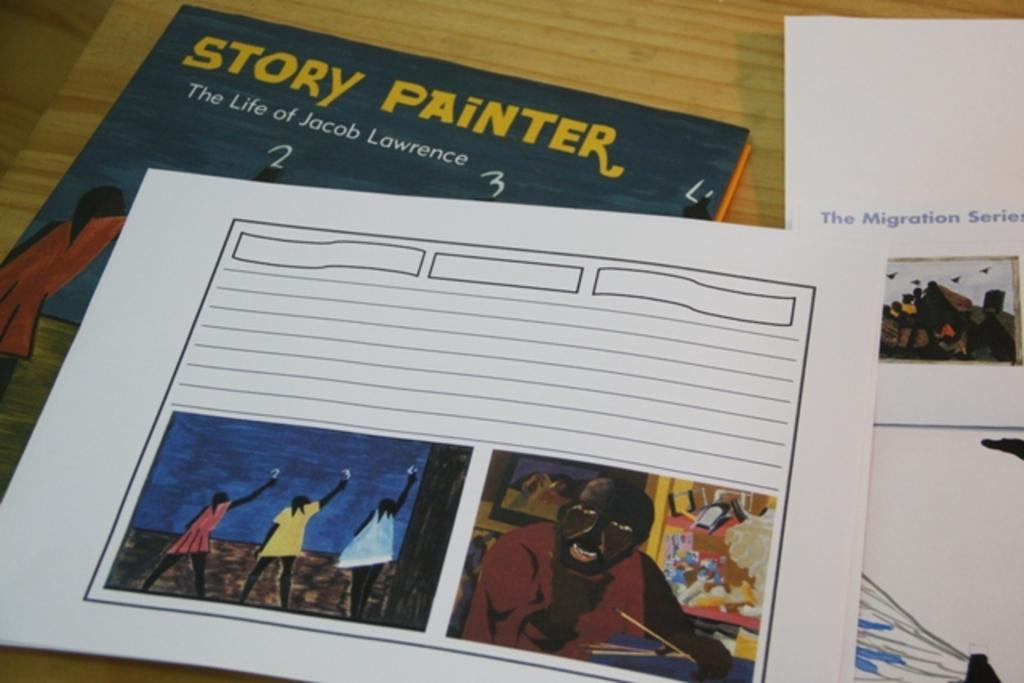Provide a one-sentence caption for the provided image. a book that is called Story Painter next to another book. 